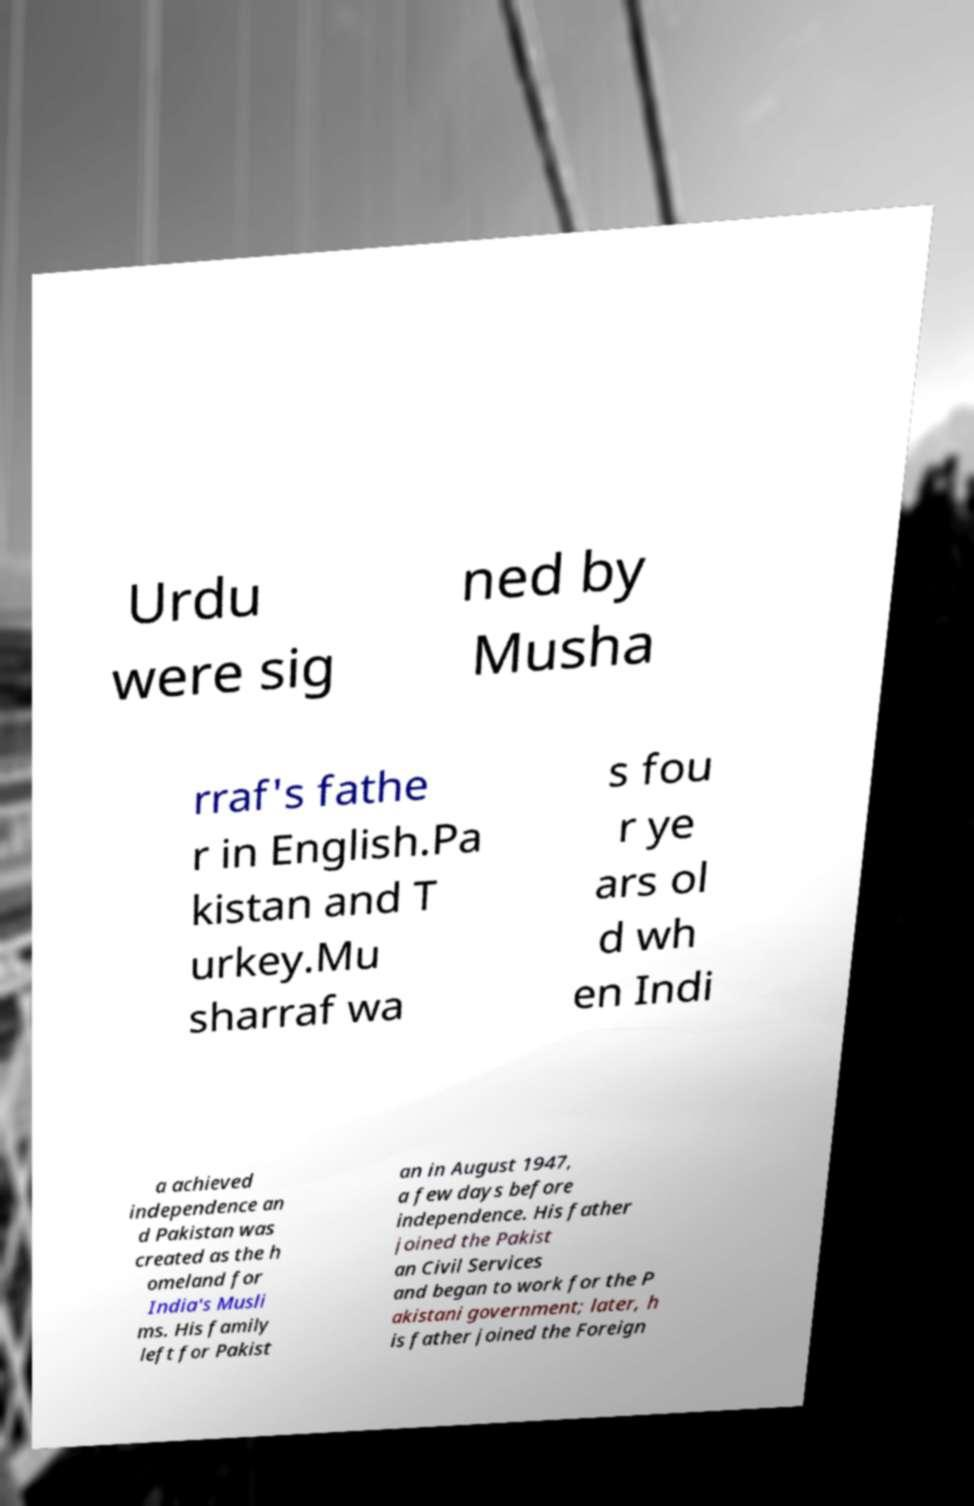Please read and relay the text visible in this image. What does it say? Urdu were sig ned by Musha rraf's fathe r in English.Pa kistan and T urkey.Mu sharraf wa s fou r ye ars ol d wh en Indi a achieved independence an d Pakistan was created as the h omeland for India's Musli ms. His family left for Pakist an in August 1947, a few days before independence. His father joined the Pakist an Civil Services and began to work for the P akistani government; later, h is father joined the Foreign 